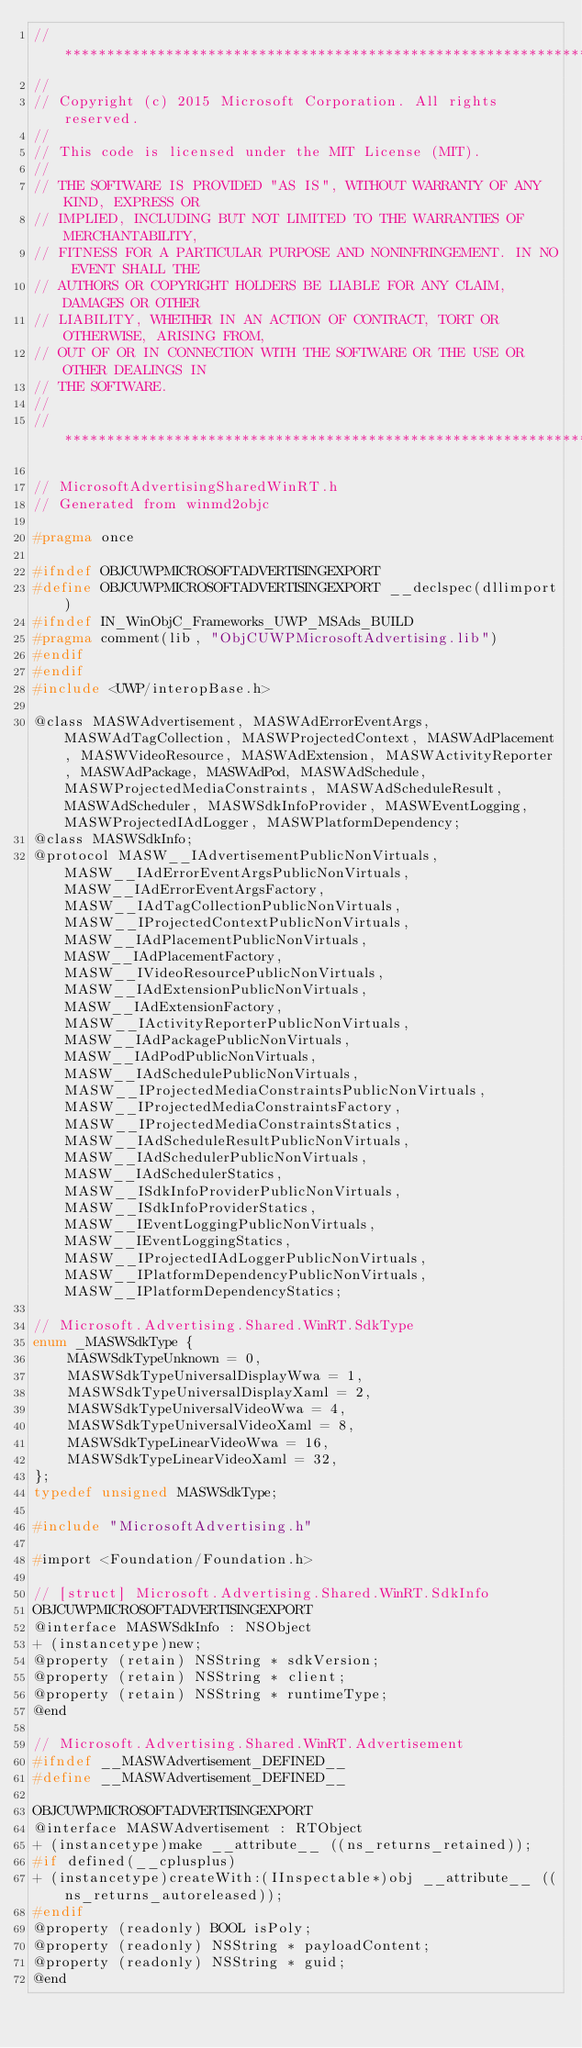Convert code to text. <code><loc_0><loc_0><loc_500><loc_500><_C_>//******************************************************************************
//
// Copyright (c) 2015 Microsoft Corporation. All rights reserved.
//
// This code is licensed under the MIT License (MIT).
//
// THE SOFTWARE IS PROVIDED "AS IS", WITHOUT WARRANTY OF ANY KIND, EXPRESS OR
// IMPLIED, INCLUDING BUT NOT LIMITED TO THE WARRANTIES OF MERCHANTABILITY,
// FITNESS FOR A PARTICULAR PURPOSE AND NONINFRINGEMENT. IN NO EVENT SHALL THE
// AUTHORS OR COPYRIGHT HOLDERS BE LIABLE FOR ANY CLAIM, DAMAGES OR OTHER
// LIABILITY, WHETHER IN AN ACTION OF CONTRACT, TORT OR OTHERWISE, ARISING FROM,
// OUT OF OR IN CONNECTION WITH THE SOFTWARE OR THE USE OR OTHER DEALINGS IN
// THE SOFTWARE.
//
//******************************************************************************

// MicrosoftAdvertisingSharedWinRT.h
// Generated from winmd2objc

#pragma once

#ifndef OBJCUWPMICROSOFTADVERTISINGEXPORT
#define OBJCUWPMICROSOFTADVERTISINGEXPORT __declspec(dllimport)
#ifndef IN_WinObjC_Frameworks_UWP_MSAds_BUILD
#pragma comment(lib, "ObjCUWPMicrosoftAdvertising.lib")
#endif
#endif
#include <UWP/interopBase.h>

@class MASWAdvertisement, MASWAdErrorEventArgs, MASWAdTagCollection, MASWProjectedContext, MASWAdPlacement, MASWVideoResource, MASWAdExtension, MASWActivityReporter, MASWAdPackage, MASWAdPod, MASWAdSchedule, MASWProjectedMediaConstraints, MASWAdScheduleResult, MASWAdScheduler, MASWSdkInfoProvider, MASWEventLogging, MASWProjectedIAdLogger, MASWPlatformDependency;
@class MASWSdkInfo;
@protocol MASW__IAdvertisementPublicNonVirtuals, MASW__IAdErrorEventArgsPublicNonVirtuals, MASW__IAdErrorEventArgsFactory, MASW__IAdTagCollectionPublicNonVirtuals, MASW__IProjectedContextPublicNonVirtuals, MASW__IAdPlacementPublicNonVirtuals, MASW__IAdPlacementFactory, MASW__IVideoResourcePublicNonVirtuals, MASW__IAdExtensionPublicNonVirtuals, MASW__IAdExtensionFactory, MASW__IActivityReporterPublicNonVirtuals, MASW__IAdPackagePublicNonVirtuals, MASW__IAdPodPublicNonVirtuals, MASW__IAdSchedulePublicNonVirtuals, MASW__IProjectedMediaConstraintsPublicNonVirtuals, MASW__IProjectedMediaConstraintsFactory, MASW__IProjectedMediaConstraintsStatics, MASW__IAdScheduleResultPublicNonVirtuals, MASW__IAdSchedulerPublicNonVirtuals, MASW__IAdSchedulerStatics, MASW__ISdkInfoProviderPublicNonVirtuals, MASW__ISdkInfoProviderStatics, MASW__IEventLoggingPublicNonVirtuals, MASW__IEventLoggingStatics, MASW__IProjectedIAdLoggerPublicNonVirtuals, MASW__IPlatformDependencyPublicNonVirtuals, MASW__IPlatformDependencyStatics;

// Microsoft.Advertising.Shared.WinRT.SdkType
enum _MASWSdkType {
    MASWSdkTypeUnknown = 0,
    MASWSdkTypeUniversalDisplayWwa = 1,
    MASWSdkTypeUniversalDisplayXaml = 2,
    MASWSdkTypeUniversalVideoWwa = 4,
    MASWSdkTypeUniversalVideoXaml = 8,
    MASWSdkTypeLinearVideoWwa = 16,
    MASWSdkTypeLinearVideoXaml = 32,
};
typedef unsigned MASWSdkType;

#include "MicrosoftAdvertising.h"

#import <Foundation/Foundation.h>

// [struct] Microsoft.Advertising.Shared.WinRT.SdkInfo
OBJCUWPMICROSOFTADVERTISINGEXPORT
@interface MASWSdkInfo : NSObject
+ (instancetype)new;
@property (retain) NSString * sdkVersion;
@property (retain) NSString * client;
@property (retain) NSString * runtimeType;
@end

// Microsoft.Advertising.Shared.WinRT.Advertisement
#ifndef __MASWAdvertisement_DEFINED__
#define __MASWAdvertisement_DEFINED__

OBJCUWPMICROSOFTADVERTISINGEXPORT
@interface MASWAdvertisement : RTObject
+ (instancetype)make __attribute__ ((ns_returns_retained));
#if defined(__cplusplus)
+ (instancetype)createWith:(IInspectable*)obj __attribute__ ((ns_returns_autoreleased));
#endif
@property (readonly) BOOL isPoly;
@property (readonly) NSString * payloadContent;
@property (readonly) NSString * guid;
@end
</code> 